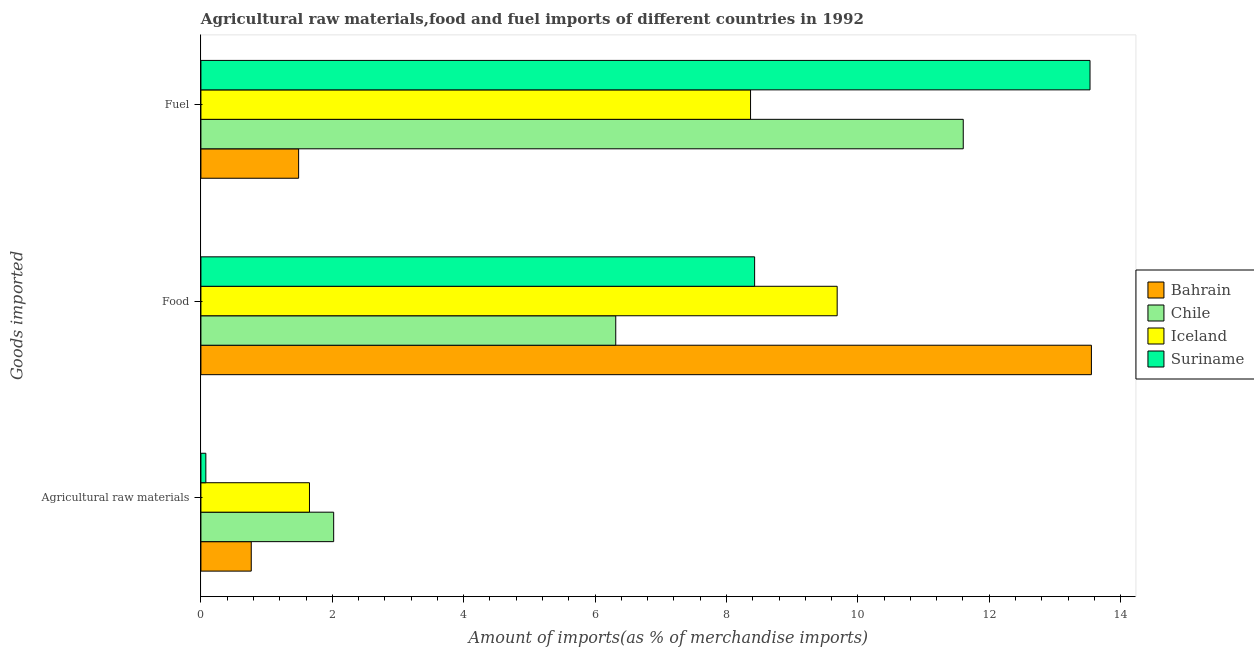Are the number of bars per tick equal to the number of legend labels?
Your answer should be very brief. Yes. How many bars are there on the 1st tick from the top?
Make the answer very short. 4. What is the label of the 3rd group of bars from the top?
Your answer should be very brief. Agricultural raw materials. What is the percentage of fuel imports in Chile?
Your answer should be compact. 11.6. Across all countries, what is the maximum percentage of food imports?
Your answer should be compact. 13.55. Across all countries, what is the minimum percentage of fuel imports?
Your answer should be compact. 1.49. In which country was the percentage of fuel imports maximum?
Provide a succinct answer. Suriname. What is the total percentage of food imports in the graph?
Your answer should be compact. 37.98. What is the difference between the percentage of fuel imports in Iceland and that in Suriname?
Your answer should be very brief. -5.17. What is the difference between the percentage of raw materials imports in Bahrain and the percentage of fuel imports in Iceland?
Provide a short and direct response. -7.6. What is the average percentage of fuel imports per country?
Your answer should be very brief. 8.75. What is the difference between the percentage of raw materials imports and percentage of fuel imports in Suriname?
Make the answer very short. -13.46. In how many countries, is the percentage of fuel imports greater than 7.2 %?
Offer a terse response. 3. What is the ratio of the percentage of raw materials imports in Chile to that in Bahrain?
Ensure brevity in your answer.  2.64. What is the difference between the highest and the second highest percentage of fuel imports?
Give a very brief answer. 1.93. What is the difference between the highest and the lowest percentage of food imports?
Keep it short and to the point. 7.24. In how many countries, is the percentage of raw materials imports greater than the average percentage of raw materials imports taken over all countries?
Keep it short and to the point. 2. What does the 2nd bar from the bottom in Agricultural raw materials represents?
Your answer should be compact. Chile. Is it the case that in every country, the sum of the percentage of raw materials imports and percentage of food imports is greater than the percentage of fuel imports?
Ensure brevity in your answer.  No. How many bars are there?
Your answer should be very brief. 12. Are all the bars in the graph horizontal?
Offer a very short reply. Yes. What is the difference between two consecutive major ticks on the X-axis?
Provide a succinct answer. 2. Does the graph contain any zero values?
Provide a succinct answer. No. Does the graph contain grids?
Offer a very short reply. No. What is the title of the graph?
Keep it short and to the point. Agricultural raw materials,food and fuel imports of different countries in 1992. Does "North America" appear as one of the legend labels in the graph?
Make the answer very short. No. What is the label or title of the X-axis?
Provide a succinct answer. Amount of imports(as % of merchandise imports). What is the label or title of the Y-axis?
Provide a short and direct response. Goods imported. What is the Amount of imports(as % of merchandise imports) of Bahrain in Agricultural raw materials?
Ensure brevity in your answer.  0.77. What is the Amount of imports(as % of merchandise imports) in Chile in Agricultural raw materials?
Offer a terse response. 2.02. What is the Amount of imports(as % of merchandise imports) in Iceland in Agricultural raw materials?
Provide a succinct answer. 1.65. What is the Amount of imports(as % of merchandise imports) of Suriname in Agricultural raw materials?
Offer a very short reply. 0.08. What is the Amount of imports(as % of merchandise imports) of Bahrain in Food?
Offer a terse response. 13.55. What is the Amount of imports(as % of merchandise imports) in Chile in Food?
Make the answer very short. 6.31. What is the Amount of imports(as % of merchandise imports) in Iceland in Food?
Offer a terse response. 9.68. What is the Amount of imports(as % of merchandise imports) of Suriname in Food?
Offer a terse response. 8.43. What is the Amount of imports(as % of merchandise imports) of Bahrain in Fuel?
Offer a very short reply. 1.49. What is the Amount of imports(as % of merchandise imports) in Chile in Fuel?
Give a very brief answer. 11.6. What is the Amount of imports(as % of merchandise imports) of Iceland in Fuel?
Provide a short and direct response. 8.37. What is the Amount of imports(as % of merchandise imports) of Suriname in Fuel?
Give a very brief answer. 13.53. Across all Goods imported, what is the maximum Amount of imports(as % of merchandise imports) of Bahrain?
Provide a succinct answer. 13.55. Across all Goods imported, what is the maximum Amount of imports(as % of merchandise imports) of Chile?
Provide a short and direct response. 11.6. Across all Goods imported, what is the maximum Amount of imports(as % of merchandise imports) in Iceland?
Your answer should be compact. 9.68. Across all Goods imported, what is the maximum Amount of imports(as % of merchandise imports) in Suriname?
Your response must be concise. 13.53. Across all Goods imported, what is the minimum Amount of imports(as % of merchandise imports) of Bahrain?
Make the answer very short. 0.77. Across all Goods imported, what is the minimum Amount of imports(as % of merchandise imports) of Chile?
Offer a very short reply. 2.02. Across all Goods imported, what is the minimum Amount of imports(as % of merchandise imports) of Iceland?
Offer a terse response. 1.65. Across all Goods imported, what is the minimum Amount of imports(as % of merchandise imports) of Suriname?
Your answer should be compact. 0.08. What is the total Amount of imports(as % of merchandise imports) of Bahrain in the graph?
Your response must be concise. 15.81. What is the total Amount of imports(as % of merchandise imports) of Chile in the graph?
Ensure brevity in your answer.  19.94. What is the total Amount of imports(as % of merchandise imports) of Iceland in the graph?
Keep it short and to the point. 19.7. What is the total Amount of imports(as % of merchandise imports) of Suriname in the graph?
Offer a terse response. 22.04. What is the difference between the Amount of imports(as % of merchandise imports) of Bahrain in Agricultural raw materials and that in Food?
Offer a terse response. -12.79. What is the difference between the Amount of imports(as % of merchandise imports) in Chile in Agricultural raw materials and that in Food?
Make the answer very short. -4.29. What is the difference between the Amount of imports(as % of merchandise imports) in Iceland in Agricultural raw materials and that in Food?
Offer a very short reply. -8.03. What is the difference between the Amount of imports(as % of merchandise imports) in Suriname in Agricultural raw materials and that in Food?
Provide a succinct answer. -8.35. What is the difference between the Amount of imports(as % of merchandise imports) of Bahrain in Agricultural raw materials and that in Fuel?
Your answer should be compact. -0.72. What is the difference between the Amount of imports(as % of merchandise imports) in Chile in Agricultural raw materials and that in Fuel?
Provide a succinct answer. -9.58. What is the difference between the Amount of imports(as % of merchandise imports) in Iceland in Agricultural raw materials and that in Fuel?
Your answer should be very brief. -6.71. What is the difference between the Amount of imports(as % of merchandise imports) in Suriname in Agricultural raw materials and that in Fuel?
Your answer should be compact. -13.46. What is the difference between the Amount of imports(as % of merchandise imports) in Bahrain in Food and that in Fuel?
Make the answer very short. 12.07. What is the difference between the Amount of imports(as % of merchandise imports) in Chile in Food and that in Fuel?
Offer a very short reply. -5.29. What is the difference between the Amount of imports(as % of merchandise imports) in Iceland in Food and that in Fuel?
Make the answer very short. 1.32. What is the difference between the Amount of imports(as % of merchandise imports) of Suriname in Food and that in Fuel?
Your response must be concise. -5.11. What is the difference between the Amount of imports(as % of merchandise imports) of Bahrain in Agricultural raw materials and the Amount of imports(as % of merchandise imports) of Chile in Food?
Your response must be concise. -5.55. What is the difference between the Amount of imports(as % of merchandise imports) in Bahrain in Agricultural raw materials and the Amount of imports(as % of merchandise imports) in Iceland in Food?
Make the answer very short. -8.92. What is the difference between the Amount of imports(as % of merchandise imports) in Bahrain in Agricultural raw materials and the Amount of imports(as % of merchandise imports) in Suriname in Food?
Make the answer very short. -7.66. What is the difference between the Amount of imports(as % of merchandise imports) of Chile in Agricultural raw materials and the Amount of imports(as % of merchandise imports) of Iceland in Food?
Keep it short and to the point. -7.66. What is the difference between the Amount of imports(as % of merchandise imports) in Chile in Agricultural raw materials and the Amount of imports(as % of merchandise imports) in Suriname in Food?
Make the answer very short. -6.41. What is the difference between the Amount of imports(as % of merchandise imports) of Iceland in Agricultural raw materials and the Amount of imports(as % of merchandise imports) of Suriname in Food?
Provide a succinct answer. -6.78. What is the difference between the Amount of imports(as % of merchandise imports) of Bahrain in Agricultural raw materials and the Amount of imports(as % of merchandise imports) of Chile in Fuel?
Your answer should be very brief. -10.84. What is the difference between the Amount of imports(as % of merchandise imports) in Bahrain in Agricultural raw materials and the Amount of imports(as % of merchandise imports) in Iceland in Fuel?
Offer a terse response. -7.6. What is the difference between the Amount of imports(as % of merchandise imports) of Bahrain in Agricultural raw materials and the Amount of imports(as % of merchandise imports) of Suriname in Fuel?
Ensure brevity in your answer.  -12.77. What is the difference between the Amount of imports(as % of merchandise imports) in Chile in Agricultural raw materials and the Amount of imports(as % of merchandise imports) in Iceland in Fuel?
Make the answer very short. -6.35. What is the difference between the Amount of imports(as % of merchandise imports) in Chile in Agricultural raw materials and the Amount of imports(as % of merchandise imports) in Suriname in Fuel?
Provide a short and direct response. -11.51. What is the difference between the Amount of imports(as % of merchandise imports) of Iceland in Agricultural raw materials and the Amount of imports(as % of merchandise imports) of Suriname in Fuel?
Your answer should be compact. -11.88. What is the difference between the Amount of imports(as % of merchandise imports) in Bahrain in Food and the Amount of imports(as % of merchandise imports) in Chile in Fuel?
Keep it short and to the point. 1.95. What is the difference between the Amount of imports(as % of merchandise imports) of Bahrain in Food and the Amount of imports(as % of merchandise imports) of Iceland in Fuel?
Make the answer very short. 5.19. What is the difference between the Amount of imports(as % of merchandise imports) in Bahrain in Food and the Amount of imports(as % of merchandise imports) in Suriname in Fuel?
Offer a terse response. 0.02. What is the difference between the Amount of imports(as % of merchandise imports) in Chile in Food and the Amount of imports(as % of merchandise imports) in Iceland in Fuel?
Make the answer very short. -2.05. What is the difference between the Amount of imports(as % of merchandise imports) in Chile in Food and the Amount of imports(as % of merchandise imports) in Suriname in Fuel?
Your answer should be very brief. -7.22. What is the difference between the Amount of imports(as % of merchandise imports) of Iceland in Food and the Amount of imports(as % of merchandise imports) of Suriname in Fuel?
Offer a very short reply. -3.85. What is the average Amount of imports(as % of merchandise imports) of Bahrain per Goods imported?
Keep it short and to the point. 5.27. What is the average Amount of imports(as % of merchandise imports) in Chile per Goods imported?
Provide a short and direct response. 6.65. What is the average Amount of imports(as % of merchandise imports) of Iceland per Goods imported?
Your answer should be compact. 6.57. What is the average Amount of imports(as % of merchandise imports) of Suriname per Goods imported?
Ensure brevity in your answer.  7.35. What is the difference between the Amount of imports(as % of merchandise imports) in Bahrain and Amount of imports(as % of merchandise imports) in Chile in Agricultural raw materials?
Offer a very short reply. -1.25. What is the difference between the Amount of imports(as % of merchandise imports) in Bahrain and Amount of imports(as % of merchandise imports) in Iceland in Agricultural raw materials?
Provide a succinct answer. -0.89. What is the difference between the Amount of imports(as % of merchandise imports) of Bahrain and Amount of imports(as % of merchandise imports) of Suriname in Agricultural raw materials?
Ensure brevity in your answer.  0.69. What is the difference between the Amount of imports(as % of merchandise imports) of Chile and Amount of imports(as % of merchandise imports) of Iceland in Agricultural raw materials?
Offer a very short reply. 0.37. What is the difference between the Amount of imports(as % of merchandise imports) in Chile and Amount of imports(as % of merchandise imports) in Suriname in Agricultural raw materials?
Provide a short and direct response. 1.95. What is the difference between the Amount of imports(as % of merchandise imports) of Iceland and Amount of imports(as % of merchandise imports) of Suriname in Agricultural raw materials?
Offer a terse response. 1.58. What is the difference between the Amount of imports(as % of merchandise imports) of Bahrain and Amount of imports(as % of merchandise imports) of Chile in Food?
Make the answer very short. 7.24. What is the difference between the Amount of imports(as % of merchandise imports) in Bahrain and Amount of imports(as % of merchandise imports) in Iceland in Food?
Offer a terse response. 3.87. What is the difference between the Amount of imports(as % of merchandise imports) in Bahrain and Amount of imports(as % of merchandise imports) in Suriname in Food?
Your response must be concise. 5.13. What is the difference between the Amount of imports(as % of merchandise imports) in Chile and Amount of imports(as % of merchandise imports) in Iceland in Food?
Your response must be concise. -3.37. What is the difference between the Amount of imports(as % of merchandise imports) in Chile and Amount of imports(as % of merchandise imports) in Suriname in Food?
Your answer should be very brief. -2.11. What is the difference between the Amount of imports(as % of merchandise imports) in Iceland and Amount of imports(as % of merchandise imports) in Suriname in Food?
Make the answer very short. 1.26. What is the difference between the Amount of imports(as % of merchandise imports) of Bahrain and Amount of imports(as % of merchandise imports) of Chile in Fuel?
Your response must be concise. -10.12. What is the difference between the Amount of imports(as % of merchandise imports) of Bahrain and Amount of imports(as % of merchandise imports) of Iceland in Fuel?
Your response must be concise. -6.88. What is the difference between the Amount of imports(as % of merchandise imports) of Bahrain and Amount of imports(as % of merchandise imports) of Suriname in Fuel?
Offer a terse response. -12.05. What is the difference between the Amount of imports(as % of merchandise imports) in Chile and Amount of imports(as % of merchandise imports) in Iceland in Fuel?
Provide a short and direct response. 3.24. What is the difference between the Amount of imports(as % of merchandise imports) of Chile and Amount of imports(as % of merchandise imports) of Suriname in Fuel?
Give a very brief answer. -1.93. What is the difference between the Amount of imports(as % of merchandise imports) of Iceland and Amount of imports(as % of merchandise imports) of Suriname in Fuel?
Your answer should be very brief. -5.17. What is the ratio of the Amount of imports(as % of merchandise imports) in Bahrain in Agricultural raw materials to that in Food?
Ensure brevity in your answer.  0.06. What is the ratio of the Amount of imports(as % of merchandise imports) in Chile in Agricultural raw materials to that in Food?
Make the answer very short. 0.32. What is the ratio of the Amount of imports(as % of merchandise imports) of Iceland in Agricultural raw materials to that in Food?
Your answer should be compact. 0.17. What is the ratio of the Amount of imports(as % of merchandise imports) of Suriname in Agricultural raw materials to that in Food?
Your answer should be very brief. 0.01. What is the ratio of the Amount of imports(as % of merchandise imports) in Bahrain in Agricultural raw materials to that in Fuel?
Provide a short and direct response. 0.52. What is the ratio of the Amount of imports(as % of merchandise imports) of Chile in Agricultural raw materials to that in Fuel?
Your response must be concise. 0.17. What is the ratio of the Amount of imports(as % of merchandise imports) in Iceland in Agricultural raw materials to that in Fuel?
Provide a short and direct response. 0.2. What is the ratio of the Amount of imports(as % of merchandise imports) of Suriname in Agricultural raw materials to that in Fuel?
Offer a terse response. 0.01. What is the ratio of the Amount of imports(as % of merchandise imports) of Bahrain in Food to that in Fuel?
Make the answer very short. 9.11. What is the ratio of the Amount of imports(as % of merchandise imports) of Chile in Food to that in Fuel?
Your answer should be very brief. 0.54. What is the ratio of the Amount of imports(as % of merchandise imports) in Iceland in Food to that in Fuel?
Give a very brief answer. 1.16. What is the ratio of the Amount of imports(as % of merchandise imports) of Suriname in Food to that in Fuel?
Your answer should be compact. 0.62. What is the difference between the highest and the second highest Amount of imports(as % of merchandise imports) in Bahrain?
Your answer should be compact. 12.07. What is the difference between the highest and the second highest Amount of imports(as % of merchandise imports) in Chile?
Provide a short and direct response. 5.29. What is the difference between the highest and the second highest Amount of imports(as % of merchandise imports) in Iceland?
Make the answer very short. 1.32. What is the difference between the highest and the second highest Amount of imports(as % of merchandise imports) in Suriname?
Provide a short and direct response. 5.11. What is the difference between the highest and the lowest Amount of imports(as % of merchandise imports) in Bahrain?
Offer a terse response. 12.79. What is the difference between the highest and the lowest Amount of imports(as % of merchandise imports) in Chile?
Ensure brevity in your answer.  9.58. What is the difference between the highest and the lowest Amount of imports(as % of merchandise imports) of Iceland?
Provide a succinct answer. 8.03. What is the difference between the highest and the lowest Amount of imports(as % of merchandise imports) in Suriname?
Your answer should be compact. 13.46. 